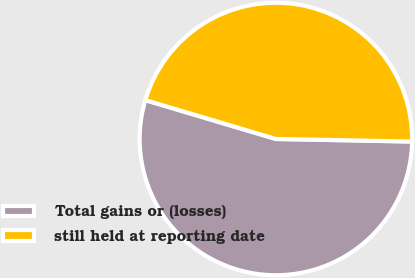<chart> <loc_0><loc_0><loc_500><loc_500><pie_chart><fcel>Total gains or (losses)<fcel>still held at reporting date<nl><fcel>54.3%<fcel>45.7%<nl></chart> 